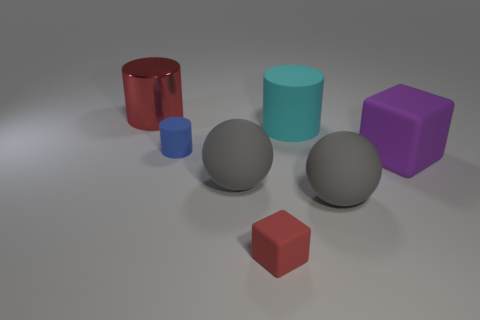There is a rubber sphere that is to the right of the rubber cube that is left of the large cyan cylinder; what color is it?
Ensure brevity in your answer.  Gray. Are there an equal number of big red metallic cylinders in front of the cyan thing and big cylinders in front of the big metal thing?
Give a very brief answer. No. How many spheres are small purple metal objects or gray things?
Make the answer very short. 2. How many other things are there of the same material as the small block?
Your response must be concise. 5. What shape is the blue thing behind the large purple block?
Give a very brief answer. Cylinder. The gray ball on the left side of the cyan cylinder that is behind the purple matte cube is made of what material?
Offer a terse response. Rubber. Are there more cyan things that are behind the big block than yellow matte objects?
Your answer should be compact. Yes. How many other things are the same color as the tiny matte cylinder?
Ensure brevity in your answer.  0. What is the shape of the cyan matte thing that is the same size as the purple matte block?
Provide a short and direct response. Cylinder. There is a large sphere that is to the right of the big matte cylinder that is to the right of the tiny matte cylinder; how many big red metallic cylinders are right of it?
Your response must be concise. 0. 